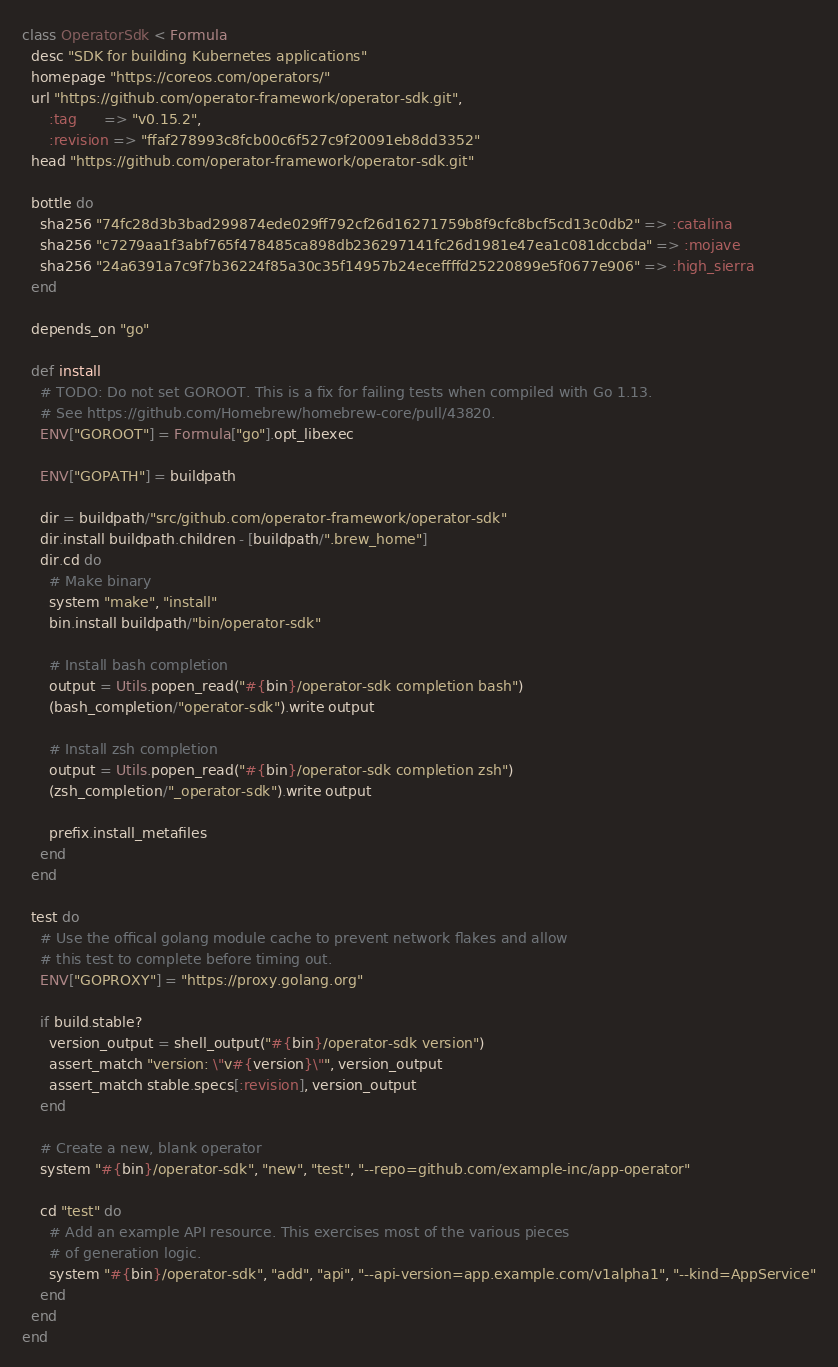<code> <loc_0><loc_0><loc_500><loc_500><_Ruby_>class OperatorSdk < Formula
  desc "SDK for building Kubernetes applications"
  homepage "https://coreos.com/operators/"
  url "https://github.com/operator-framework/operator-sdk.git",
      :tag      => "v0.15.2",
      :revision => "ffaf278993c8fcb00c6f527c9f20091eb8dd3352"
  head "https://github.com/operator-framework/operator-sdk.git"

  bottle do
    sha256 "74fc28d3b3bad299874ede029ff792cf26d16271759b8f9cfc8bcf5cd13c0db2" => :catalina
    sha256 "c7279aa1f3abf765f478485ca898db236297141fc26d1981e47ea1c081dccbda" => :mojave
    sha256 "24a6391a7c9f7b36224f85a30c35f14957b24eceffffd25220899e5f0677e906" => :high_sierra
  end

  depends_on "go"

  def install
    # TODO: Do not set GOROOT. This is a fix for failing tests when compiled with Go 1.13.
    # See https://github.com/Homebrew/homebrew-core/pull/43820.
    ENV["GOROOT"] = Formula["go"].opt_libexec

    ENV["GOPATH"] = buildpath

    dir = buildpath/"src/github.com/operator-framework/operator-sdk"
    dir.install buildpath.children - [buildpath/".brew_home"]
    dir.cd do
      # Make binary
      system "make", "install"
      bin.install buildpath/"bin/operator-sdk"

      # Install bash completion
      output = Utils.popen_read("#{bin}/operator-sdk completion bash")
      (bash_completion/"operator-sdk").write output

      # Install zsh completion
      output = Utils.popen_read("#{bin}/operator-sdk completion zsh")
      (zsh_completion/"_operator-sdk").write output

      prefix.install_metafiles
    end
  end

  test do
    # Use the offical golang module cache to prevent network flakes and allow
    # this test to complete before timing out.
    ENV["GOPROXY"] = "https://proxy.golang.org"

    if build.stable?
      version_output = shell_output("#{bin}/operator-sdk version")
      assert_match "version: \"v#{version}\"", version_output
      assert_match stable.specs[:revision], version_output
    end

    # Create a new, blank operator
    system "#{bin}/operator-sdk", "new", "test", "--repo=github.com/example-inc/app-operator"

    cd "test" do
      # Add an example API resource. This exercises most of the various pieces
      # of generation logic.
      system "#{bin}/operator-sdk", "add", "api", "--api-version=app.example.com/v1alpha1", "--kind=AppService"
    end
  end
end
</code> 